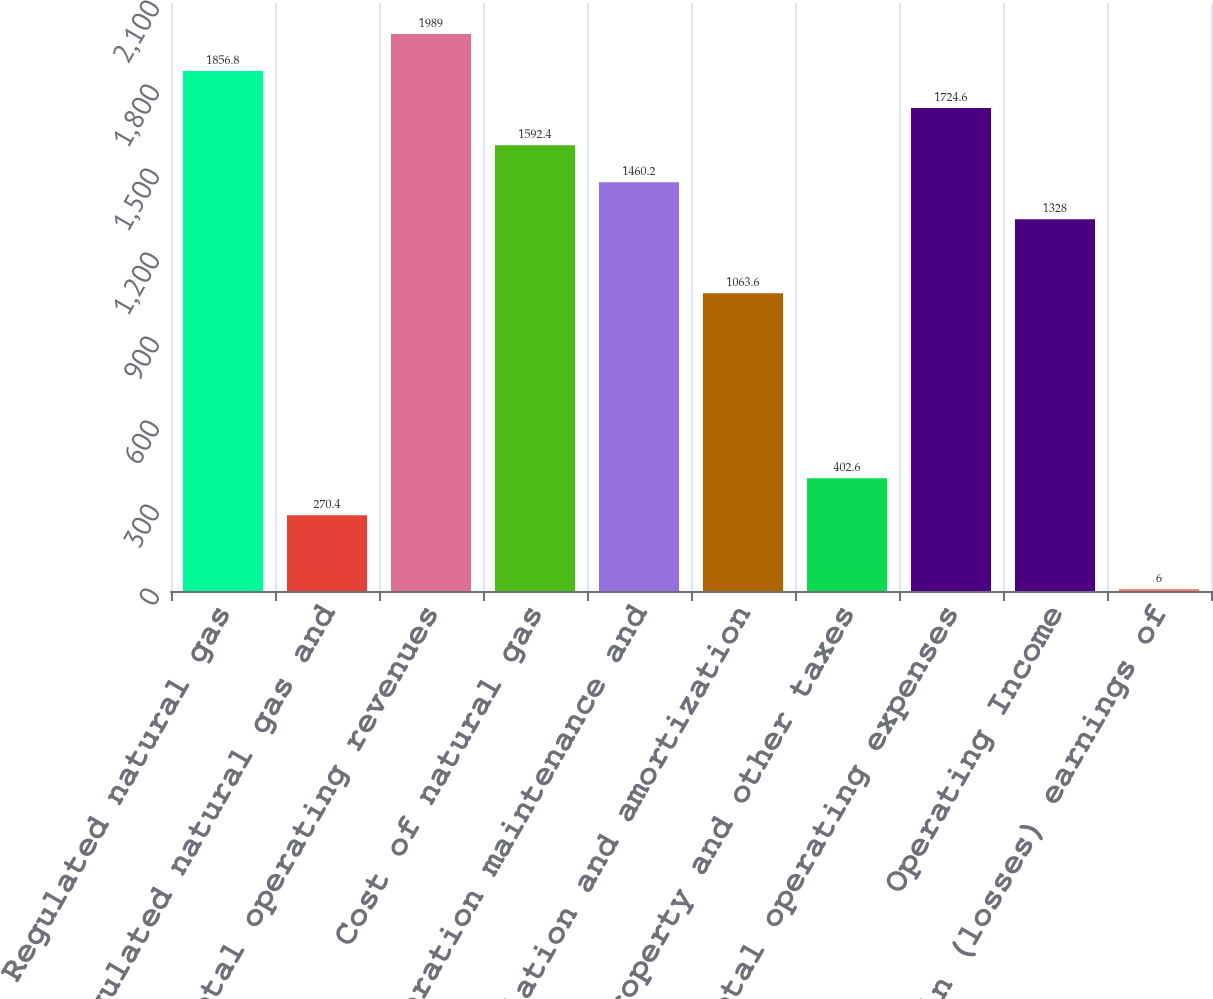Convert chart to OTSL. <chart><loc_0><loc_0><loc_500><loc_500><bar_chart><fcel>Regulated natural gas<fcel>Nonregulated natural gas and<fcel>Total operating revenues<fcel>Cost of natural gas<fcel>Operation maintenance and<fcel>Depreciation and amortization<fcel>Property and other taxes<fcel>Total operating expenses<fcel>Operating Income<fcel>Equity in (losses) earnings of<nl><fcel>1856.8<fcel>270.4<fcel>1989<fcel>1592.4<fcel>1460.2<fcel>1063.6<fcel>402.6<fcel>1724.6<fcel>1328<fcel>6<nl></chart> 